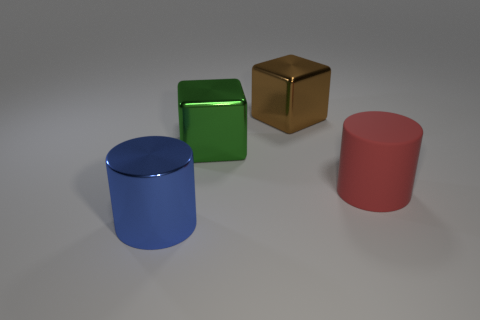Are there any other things that have the same material as the big red cylinder?
Your answer should be very brief. No. Are there any large shiny objects in front of the blue thing?
Your answer should be compact. No. Is the brown object made of the same material as the big green thing?
Your answer should be compact. Yes. There is a blue object that is the same size as the brown thing; what is it made of?
Your answer should be compact. Metal. What number of things are metal objects that are in front of the green cube or metallic cylinders?
Offer a terse response. 1. Are there the same number of large green shiny blocks on the left side of the green cube and big rubber objects?
Your answer should be very brief. No. The big thing that is in front of the green metal cube and left of the large red object is what color?
Keep it short and to the point. Blue. What number of balls are big red things or green shiny objects?
Make the answer very short. 0. Is the number of large blue cylinders that are in front of the large brown object less than the number of big shiny things?
Offer a terse response. Yes. What shape is the big brown thing that is made of the same material as the green thing?
Give a very brief answer. Cube. 